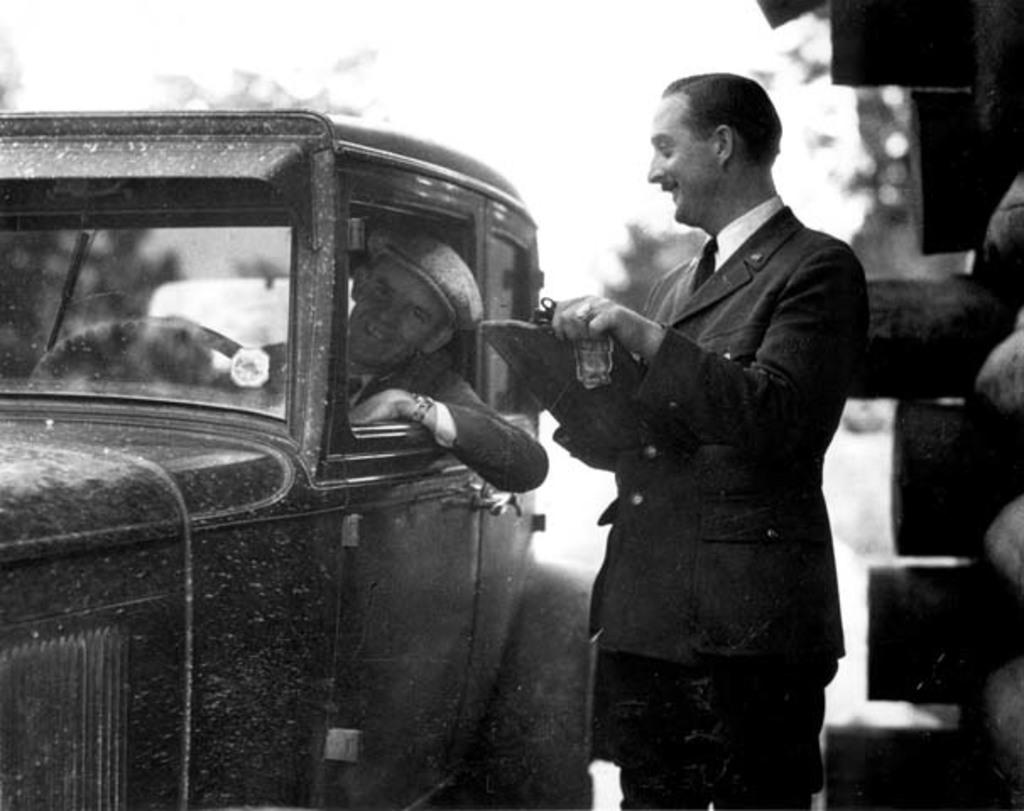What is the primary action of the man in the image? There is a man standing in the image. Can you describe the position of the second man in the image? The second man is sitting in a car in the image. What color scheme is used in the image? The image is in black and white color. What type of hose is being used by the man's aunt in the image? There is no mention of an aunt or a hose in the image, so it cannot be determined from the image. 